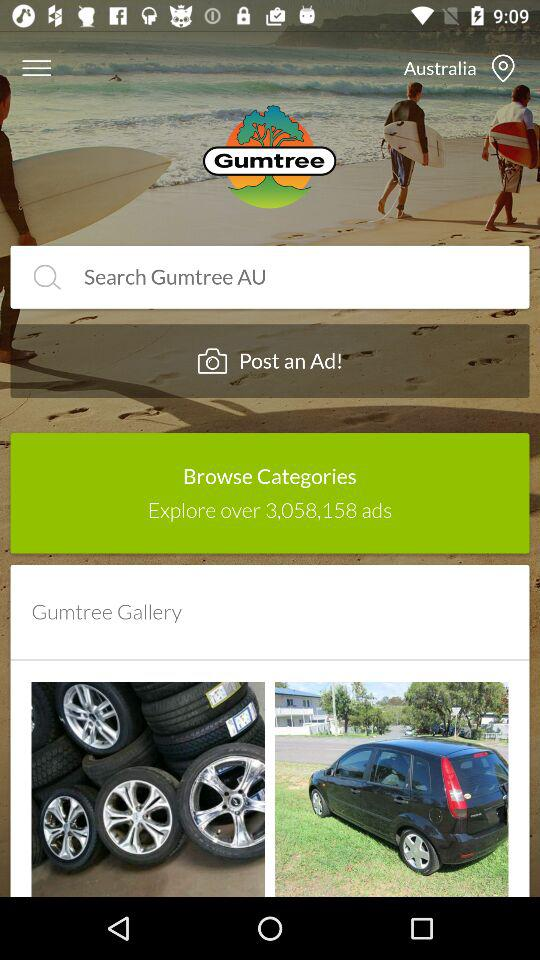How many ads can we explore? You can explore over 3,058,158 ads. 